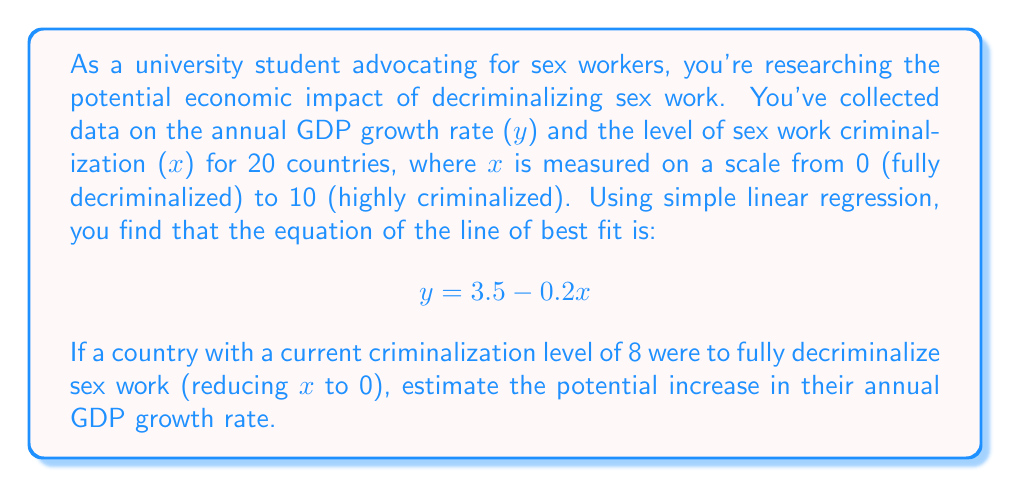Can you answer this question? To solve this problem, we'll use the given regression equation and calculate the difference in y (GDP growth rate) when x (criminalization level) changes from 8 to 0.

1. First, let's calculate y when x = 8 (current situation):
   $$ y_1 = 3.5 - 0.2(8) = 3.5 - 1.6 = 1.9\% $$

2. Now, let's calculate y when x = 0 (fully decriminalized):
   $$ y_2 = 3.5 - 0.2(0) = 3.5\% $$

3. The potential increase in GDP growth rate is the difference between these two values:
   $$ \text{Increase} = y_2 - y_1 = 3.5\% - 1.9\% = 1.6\% $$

This means that, based on the regression analysis, fully decriminalizing sex work could potentially increase the country's annual GDP growth rate by 1.6 percentage points.

It's important to note that this is a simplified model and actual economic impacts may be more complex. Factors such as changes in tax revenue, healthcare costs, and law enforcement expenditures would also need to be considered for a comprehensive analysis.
Answer: The potential increase in annual GDP growth rate is 1.6 percentage points. 